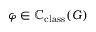Convert formula to latex. <formula><loc_0><loc_0><loc_500><loc_500>\varphi \in \mathbb { C } _ { c l a s s } ( G )</formula> 